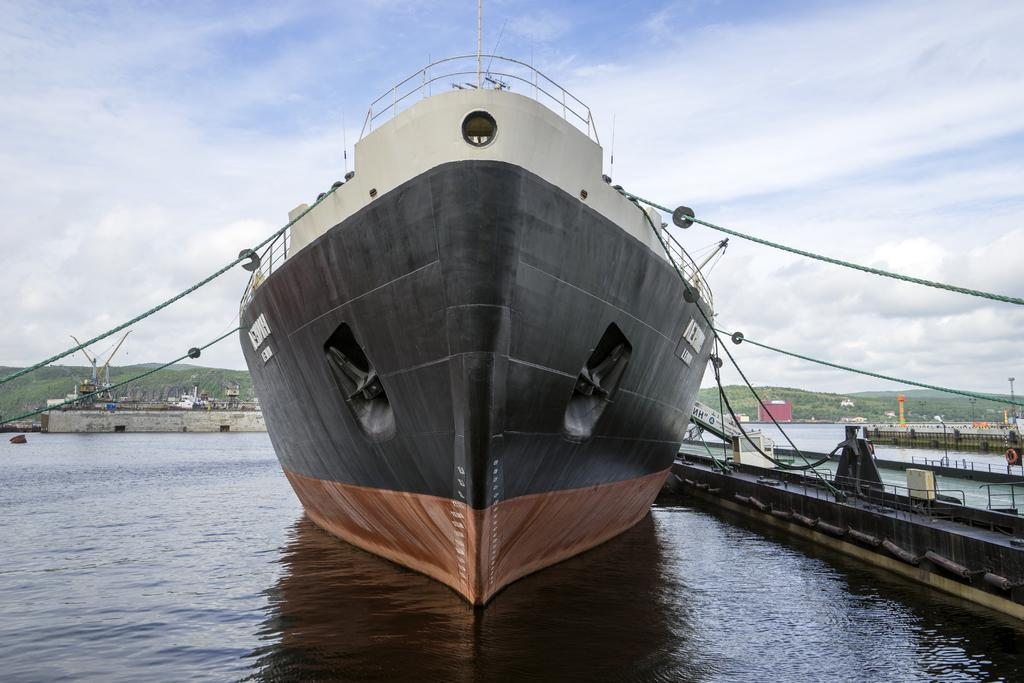What is the main subject of the image? There is a ship in the image. Where is the ship located? The ship is on water. What can be seen in the background of the image? There are trees and sky visible in the background of the image. Can you describe any other objects in the background? There are some unspecified objects in the background of the image. Can you tell me how many wrens are perched on the ship's mast in the image? There are no wrens present in the image, so it is not possible to determine how many would be perched on the ship's mast. 